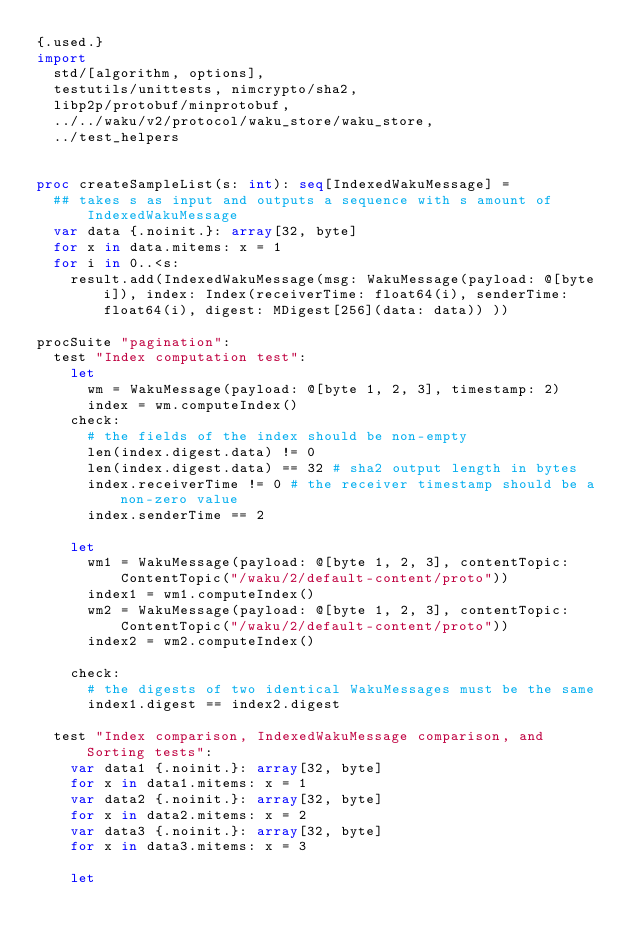Convert code to text. <code><loc_0><loc_0><loc_500><loc_500><_Nim_>{.used.}
import
  std/[algorithm, options],
  testutils/unittests, nimcrypto/sha2,
  libp2p/protobuf/minprotobuf,
  ../../waku/v2/protocol/waku_store/waku_store,
  ../test_helpers


proc createSampleList(s: int): seq[IndexedWakuMessage] =
  ## takes s as input and outputs a sequence with s amount of IndexedWakuMessage 
  var data {.noinit.}: array[32, byte]
  for x in data.mitems: x = 1
  for i in 0..<s:
    result.add(IndexedWakuMessage(msg: WakuMessage(payload: @[byte i]), index: Index(receiverTime: float64(i), senderTime: float64(i), digest: MDigest[256](data: data)) ))

procSuite "pagination":
  test "Index computation test":
    let
      wm = WakuMessage(payload: @[byte 1, 2, 3], timestamp: 2)
      index = wm.computeIndex()
    check:
      # the fields of the index should be non-empty
      len(index.digest.data) != 0
      len(index.digest.data) == 32 # sha2 output length in bytes
      index.receiverTime != 0 # the receiver timestamp should be a non-zero value
      index.senderTime == 2 

    let
      wm1 = WakuMessage(payload: @[byte 1, 2, 3], contentTopic: ContentTopic("/waku/2/default-content/proto"))
      index1 = wm1.computeIndex()
      wm2 = WakuMessage(payload: @[byte 1, 2, 3], contentTopic: ContentTopic("/waku/2/default-content/proto"))
      index2 = wm2.computeIndex()

    check:
      # the digests of two identical WakuMessages must be the same
      index1.digest == index2.digest

  test "Index comparison, IndexedWakuMessage comparison, and Sorting tests":
    var data1 {.noinit.}: array[32, byte]
    for x in data1.mitems: x = 1
    var data2 {.noinit.}: array[32, byte]
    for x in data2.mitems: x = 2
    var data3 {.noinit.}: array[32, byte]
    for x in data3.mitems: x = 3
      
    let</code> 